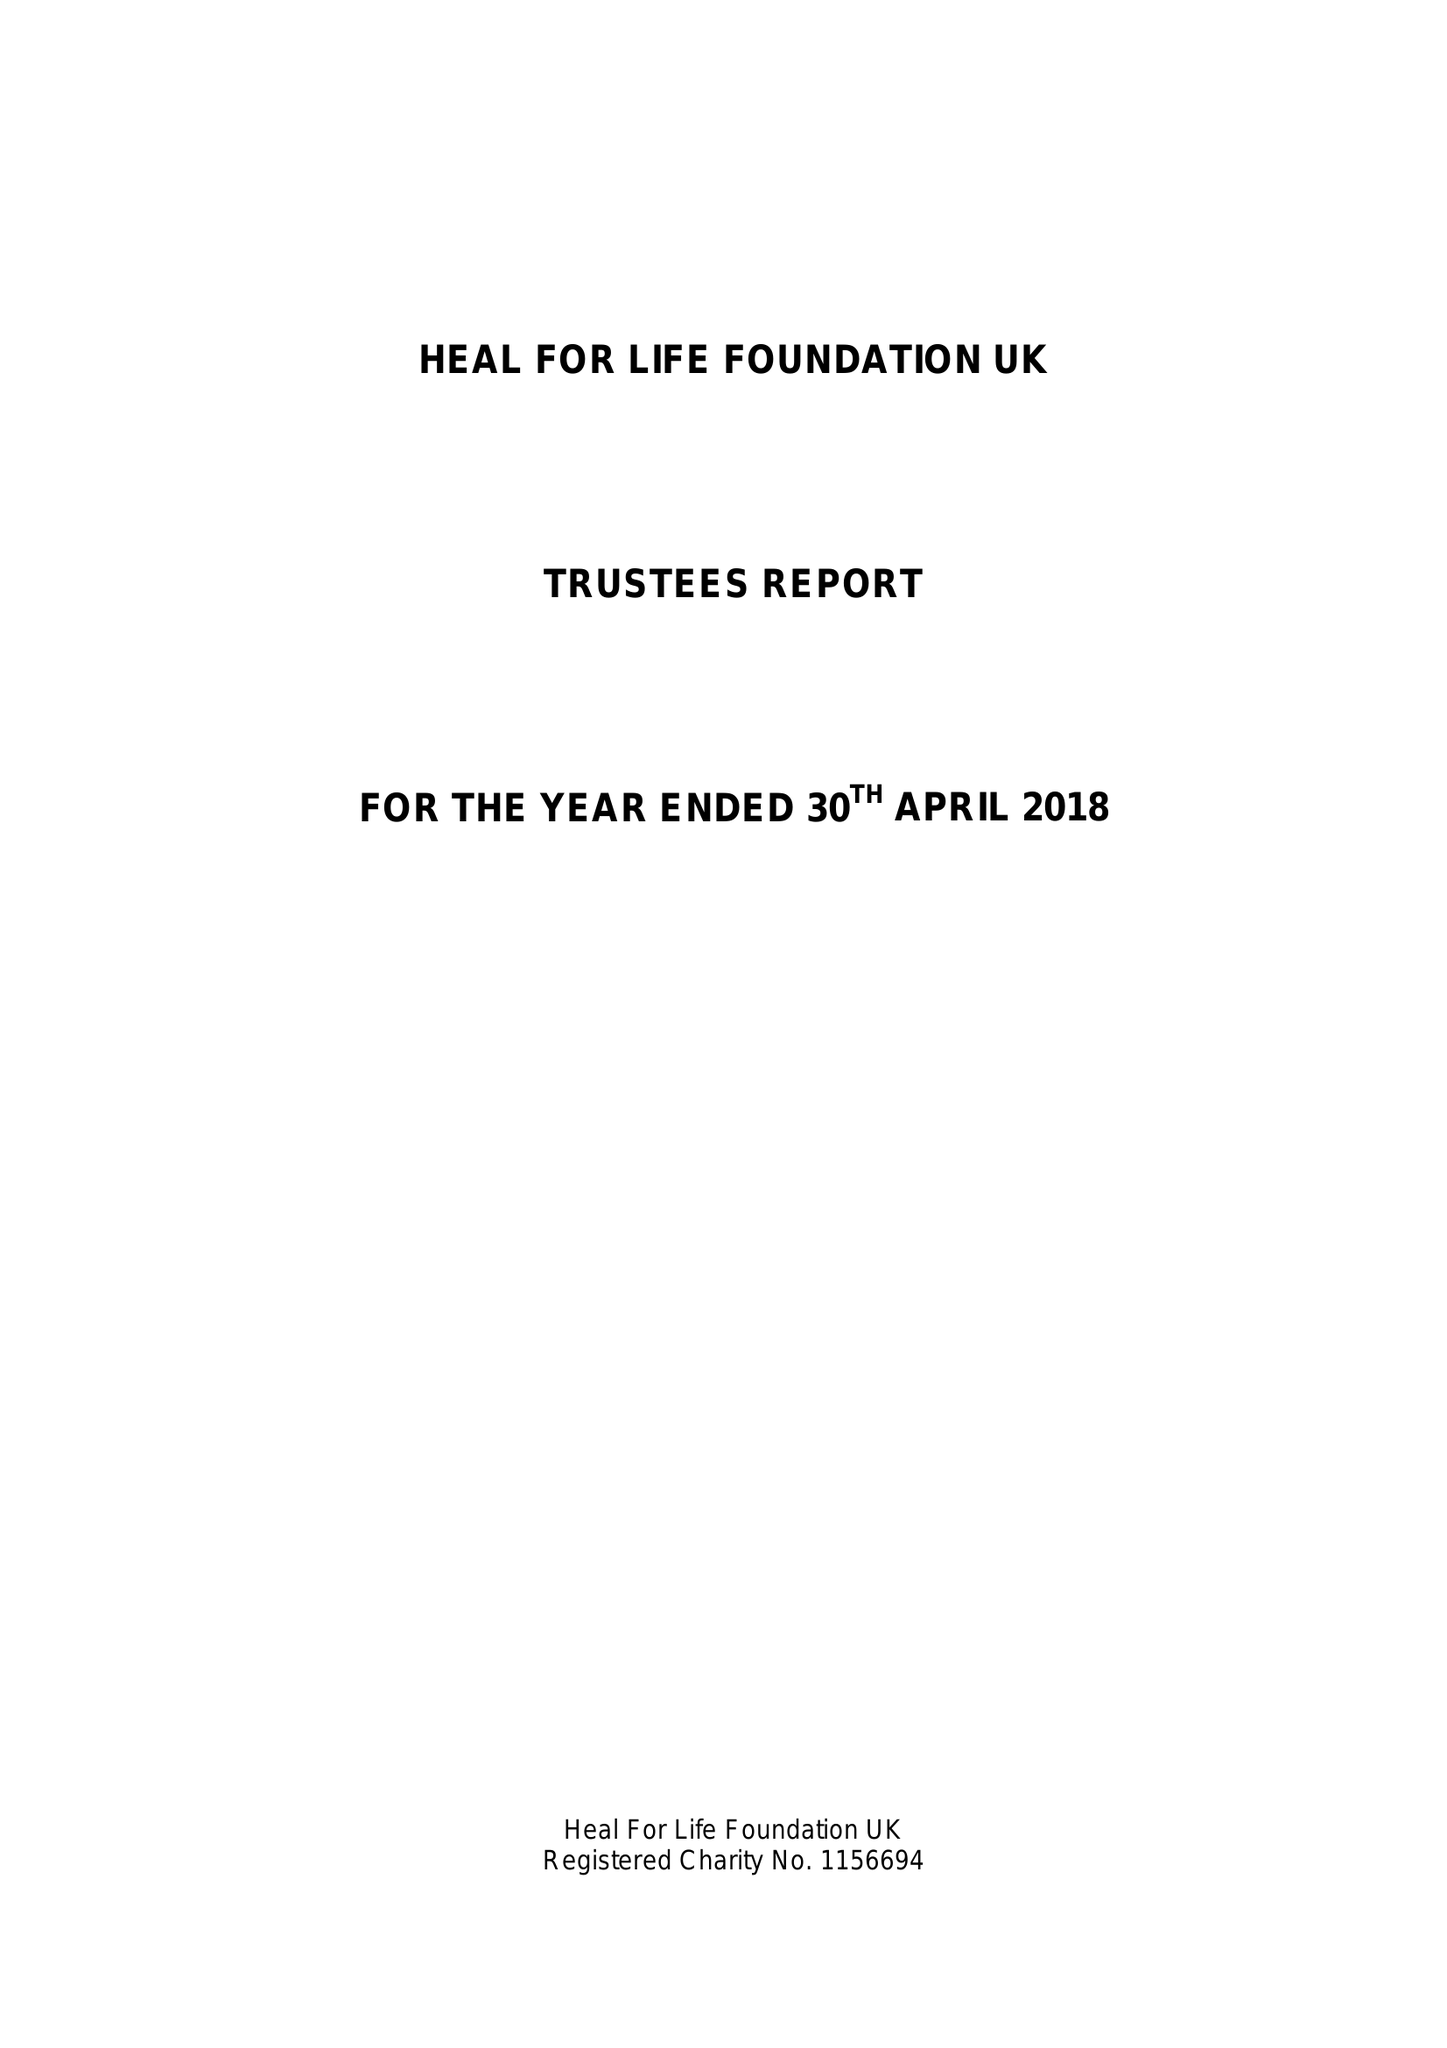What is the value for the address__street_line?
Answer the question using a single word or phrase. 24 CHURCH STREET 